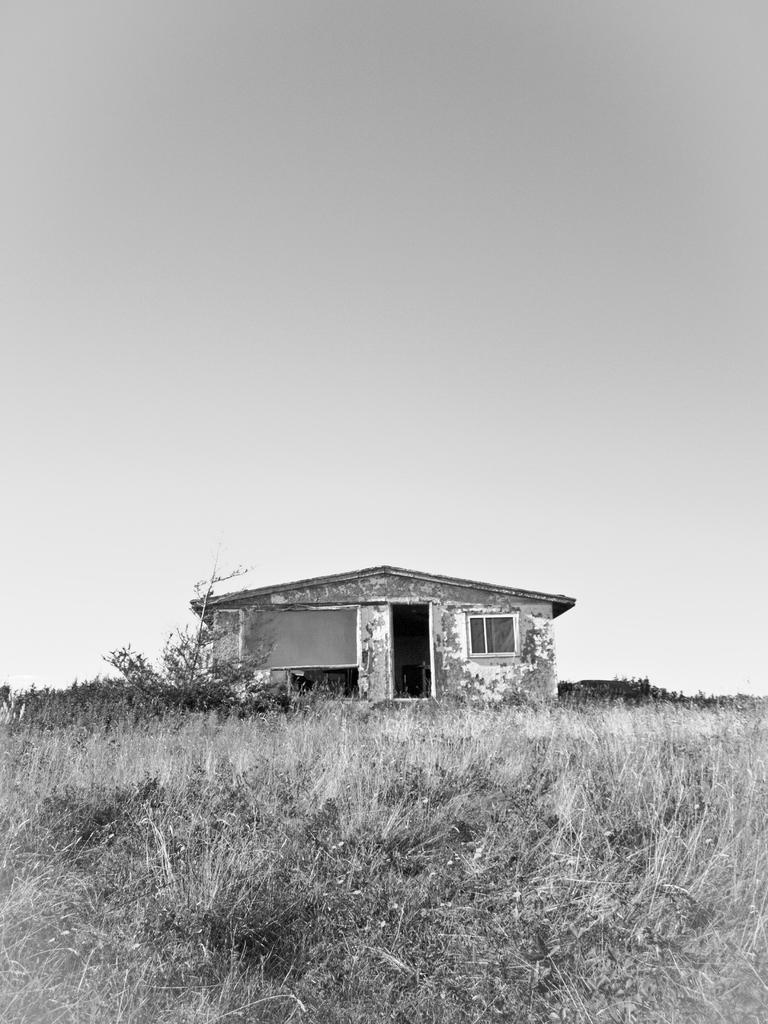What type of structure is visible in the image? There is a house in the image. What features can be seen in front of the house? There is a door, a window, and a board in front of the house. What type of vegetation is visible at the bottom of the image? There is grass visible at the bottom of the image. What is visible at the top of the image? The sky is visible at the top of the image. Where is the nest located in the image? There is no nest present in the image. How many wings can be seen on the house in the image? The house does not have wings; it is a stationary structure. 